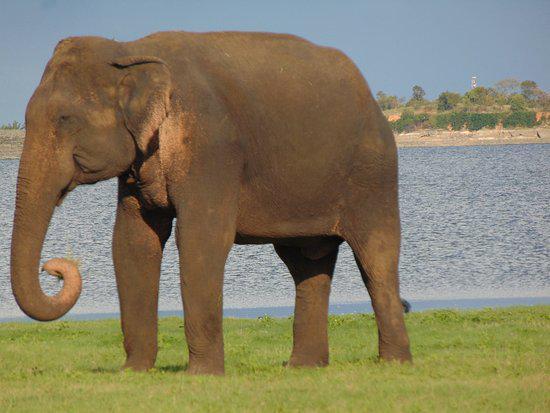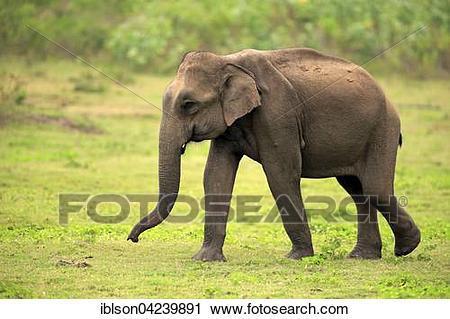The first image is the image on the left, the second image is the image on the right. Examine the images to the left and right. Is the description "All elephants have ivory tusks." accurate? Answer yes or no. No. 